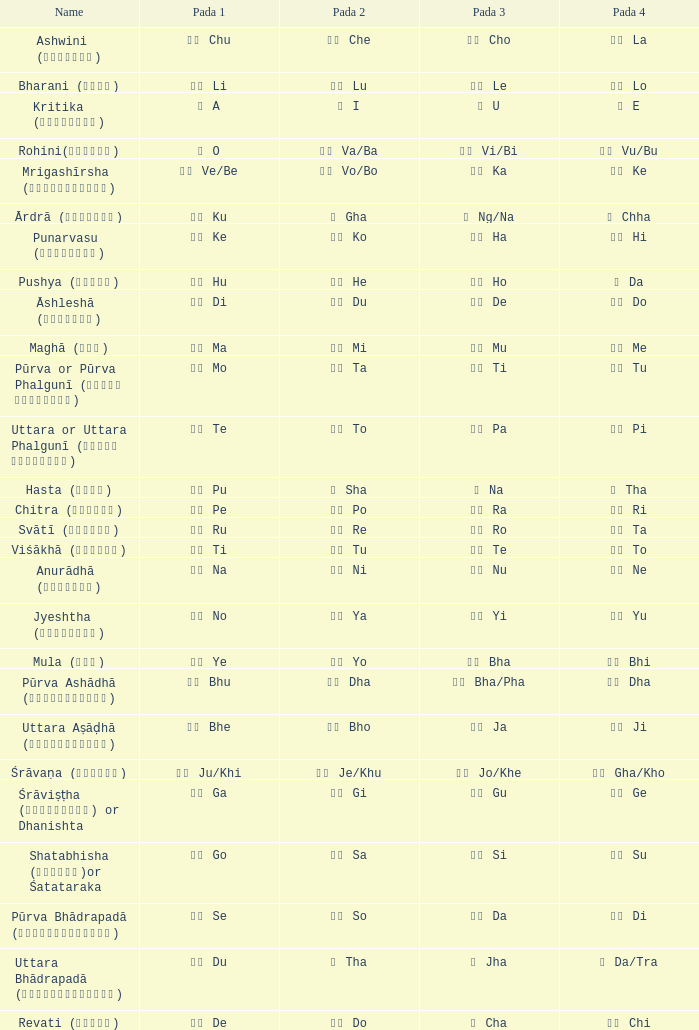What kind of Pada 4 has a Pada 1 of खी ju/khi? खो Gha/Kho. Help me parse the entirety of this table. {'header': ['Name', 'Pada 1', 'Pada 2', 'Pada 3', 'Pada 4'], 'rows': [['Ashwini (अश्विनि)', 'चु Chu', 'चे Che', 'चो Cho', 'ला La'], ['Bharani (भरणी)', 'ली Li', 'लू Lu', 'ले Le', 'लो Lo'], ['Kritika (कृत्तिका)', 'अ A', 'ई I', 'उ U', 'ए E'], ['Rohini(रोहिणी)', 'ओ O', 'वा Va/Ba', 'वी Vi/Bi', 'वु Vu/Bu'], ['Mrigashīrsha (म्रृगशीर्षा)', 'वे Ve/Be', 'वो Vo/Bo', 'का Ka', 'की Ke'], ['Ārdrā (आर्द्रा)', 'कु Ku', 'घ Gha', 'ङ Ng/Na', 'छ Chha'], ['Punarvasu (पुनर्वसु)', 'के Ke', 'को Ko', 'हा Ha', 'ही Hi'], ['Pushya (पुष्य)', 'हु Hu', 'हे He', 'हो Ho', 'ड Da'], ['Āshleshā (आश्लेषा)', 'डी Di', 'डू Du', 'डे De', 'डो Do'], ['Maghā (मघा)', 'मा Ma', 'मी Mi', 'मू Mu', 'मे Me'], ['Pūrva or Pūrva Phalgunī (पूर्व फाल्गुनी)', 'नो Mo', 'टा Ta', 'टी Ti', 'टू Tu'], ['Uttara or Uttara Phalgunī (उत्तर फाल्गुनी)', 'टे Te', 'टो To', 'पा Pa', 'पी Pi'], ['Hasta (हस्त)', 'पू Pu', 'ष Sha', 'ण Na', 'ठ Tha'], ['Chitra (चित्रा)', 'पे Pe', 'पो Po', 'रा Ra', 'री Ri'], ['Svātī (स्वाति)', 'रू Ru', 'रे Re', 'रो Ro', 'ता Ta'], ['Viśākhā (विशाखा)', 'ती Ti', 'तू Tu', 'ते Te', 'तो To'], ['Anurādhā (अनुराधा)', 'ना Na', 'नी Ni', 'नू Nu', 'ने Ne'], ['Jyeshtha (ज्येष्ठा)', 'नो No', 'या Ya', 'यी Yi', 'यू Yu'], ['Mula (मूल)', 'ये Ye', 'यो Yo', 'भा Bha', 'भी Bhi'], ['Pūrva Ashādhā (पूर्वाषाढ़ा)', 'भू Bhu', 'धा Dha', 'फा Bha/Pha', 'ढा Dha'], ['Uttara Aṣāḍhā (उत्तराषाढ़ा)', 'भे Bhe', 'भो Bho', 'जा Ja', 'जी Ji'], ['Śrāvaṇa (श्र\u200cावण)', 'खी Ju/Khi', 'खू Je/Khu', 'खे Jo/Khe', 'खो Gha/Kho'], ['Śrāviṣṭha (श्रविष्ठा) or Dhanishta', 'गा Ga', 'गी Gi', 'गु Gu', 'गे Ge'], ['Shatabhisha (शतभिषा)or Śatataraka', 'गो Go', 'सा Sa', 'सी Si', 'सू Su'], ['Pūrva Bhādrapadā (पूर्वभाद्रपदा)', 'से Se', 'सो So', 'दा Da', 'दी Di'], ['Uttara Bhādrapadā (उत्तरभाद्रपदा)', 'दू Du', 'थ Tha', 'झ Jha', 'ञ Da/Tra'], ['Revati (रेवती)', 'दे De', 'दो Do', 'च Cha', 'ची Chi']]} 